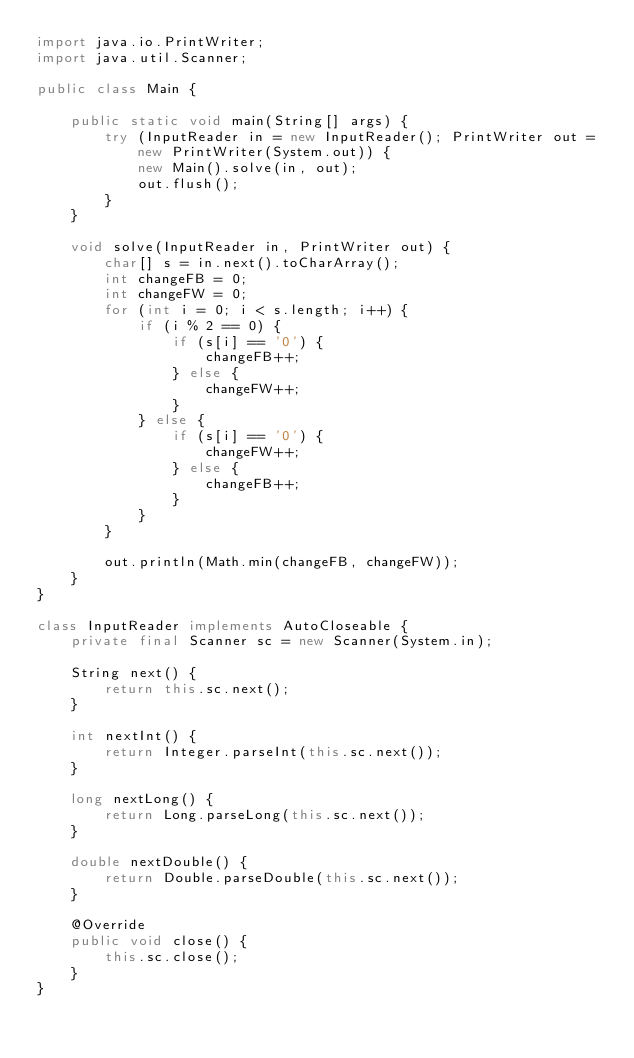<code> <loc_0><loc_0><loc_500><loc_500><_Java_>import java.io.PrintWriter;
import java.util.Scanner;

public class Main {

    public static void main(String[] args) {
        try (InputReader in = new InputReader(); PrintWriter out = new PrintWriter(System.out)) {
            new Main().solve(in, out);
            out.flush();
        }
    }

    void solve(InputReader in, PrintWriter out) {
        char[] s = in.next().toCharArray();
        int changeFB = 0;
        int changeFW = 0;
        for (int i = 0; i < s.length; i++) {
            if (i % 2 == 0) {
                if (s[i] == '0') {
                    changeFB++;
                } else {
                    changeFW++;
                }
            } else {
                if (s[i] == '0') {
                    changeFW++;
                } else {
                    changeFB++;
                }
            }
        }

        out.println(Math.min(changeFB, changeFW));
    }
}

class InputReader implements AutoCloseable {
    private final Scanner sc = new Scanner(System.in);

    String next() {
        return this.sc.next();
    }

    int nextInt() {
        return Integer.parseInt(this.sc.next());
    }

    long nextLong() {
        return Long.parseLong(this.sc.next());
    }

    double nextDouble() {
        return Double.parseDouble(this.sc.next());
    }

    @Override
    public void close() {
        this.sc.close();
    }
}</code> 